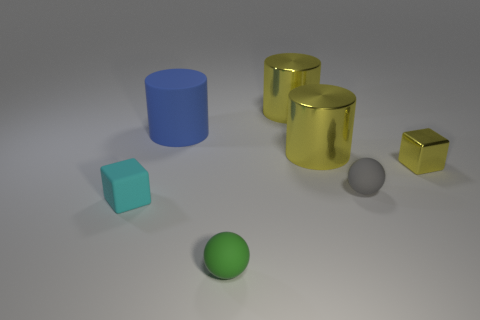Add 1 green balls. How many objects exist? 8 Subtract all cylinders. How many objects are left? 4 Subtract 0 purple cubes. How many objects are left? 7 Subtract all tiny purple metallic things. Subtract all cyan blocks. How many objects are left? 6 Add 5 small cyan matte objects. How many small cyan matte objects are left? 6 Add 2 green spheres. How many green spheres exist? 3 